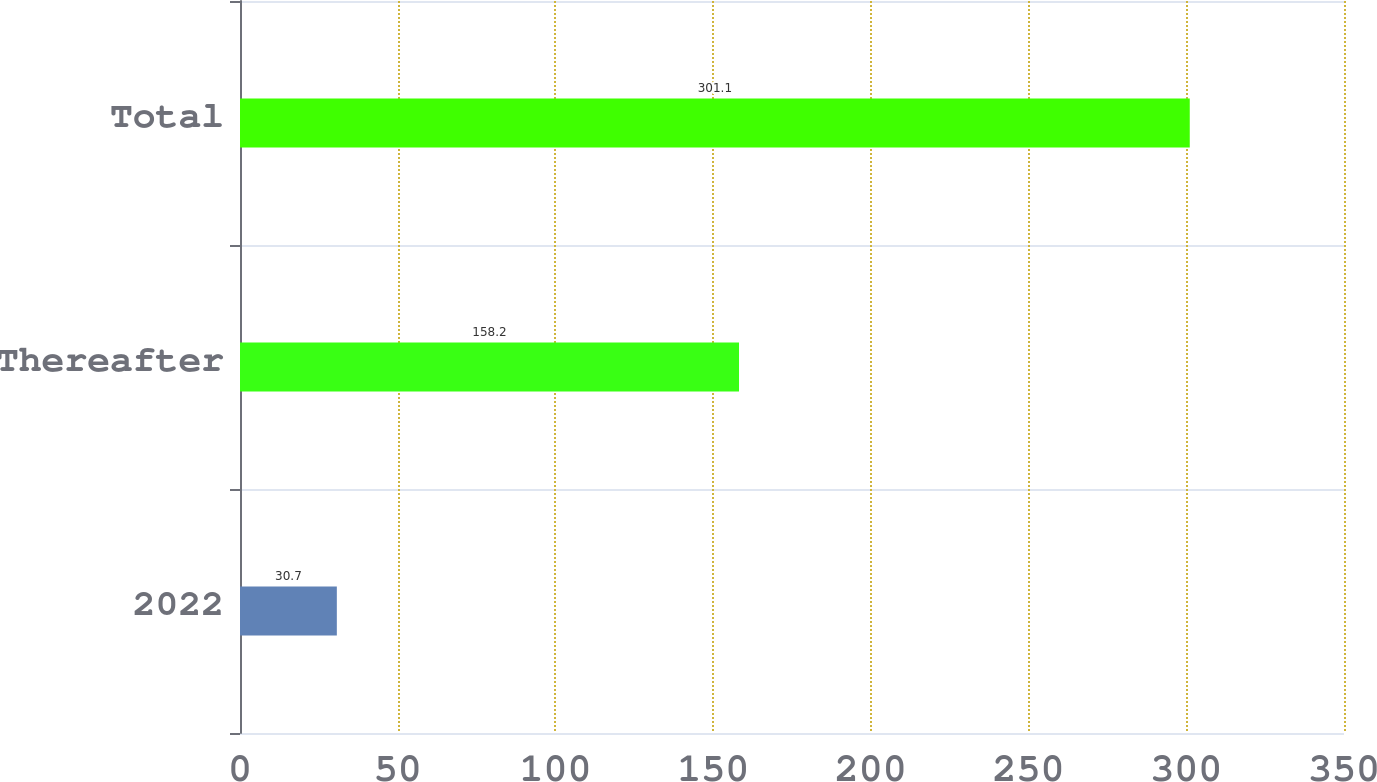<chart> <loc_0><loc_0><loc_500><loc_500><bar_chart><fcel>2022<fcel>Thereafter<fcel>Total<nl><fcel>30.7<fcel>158.2<fcel>301.1<nl></chart> 